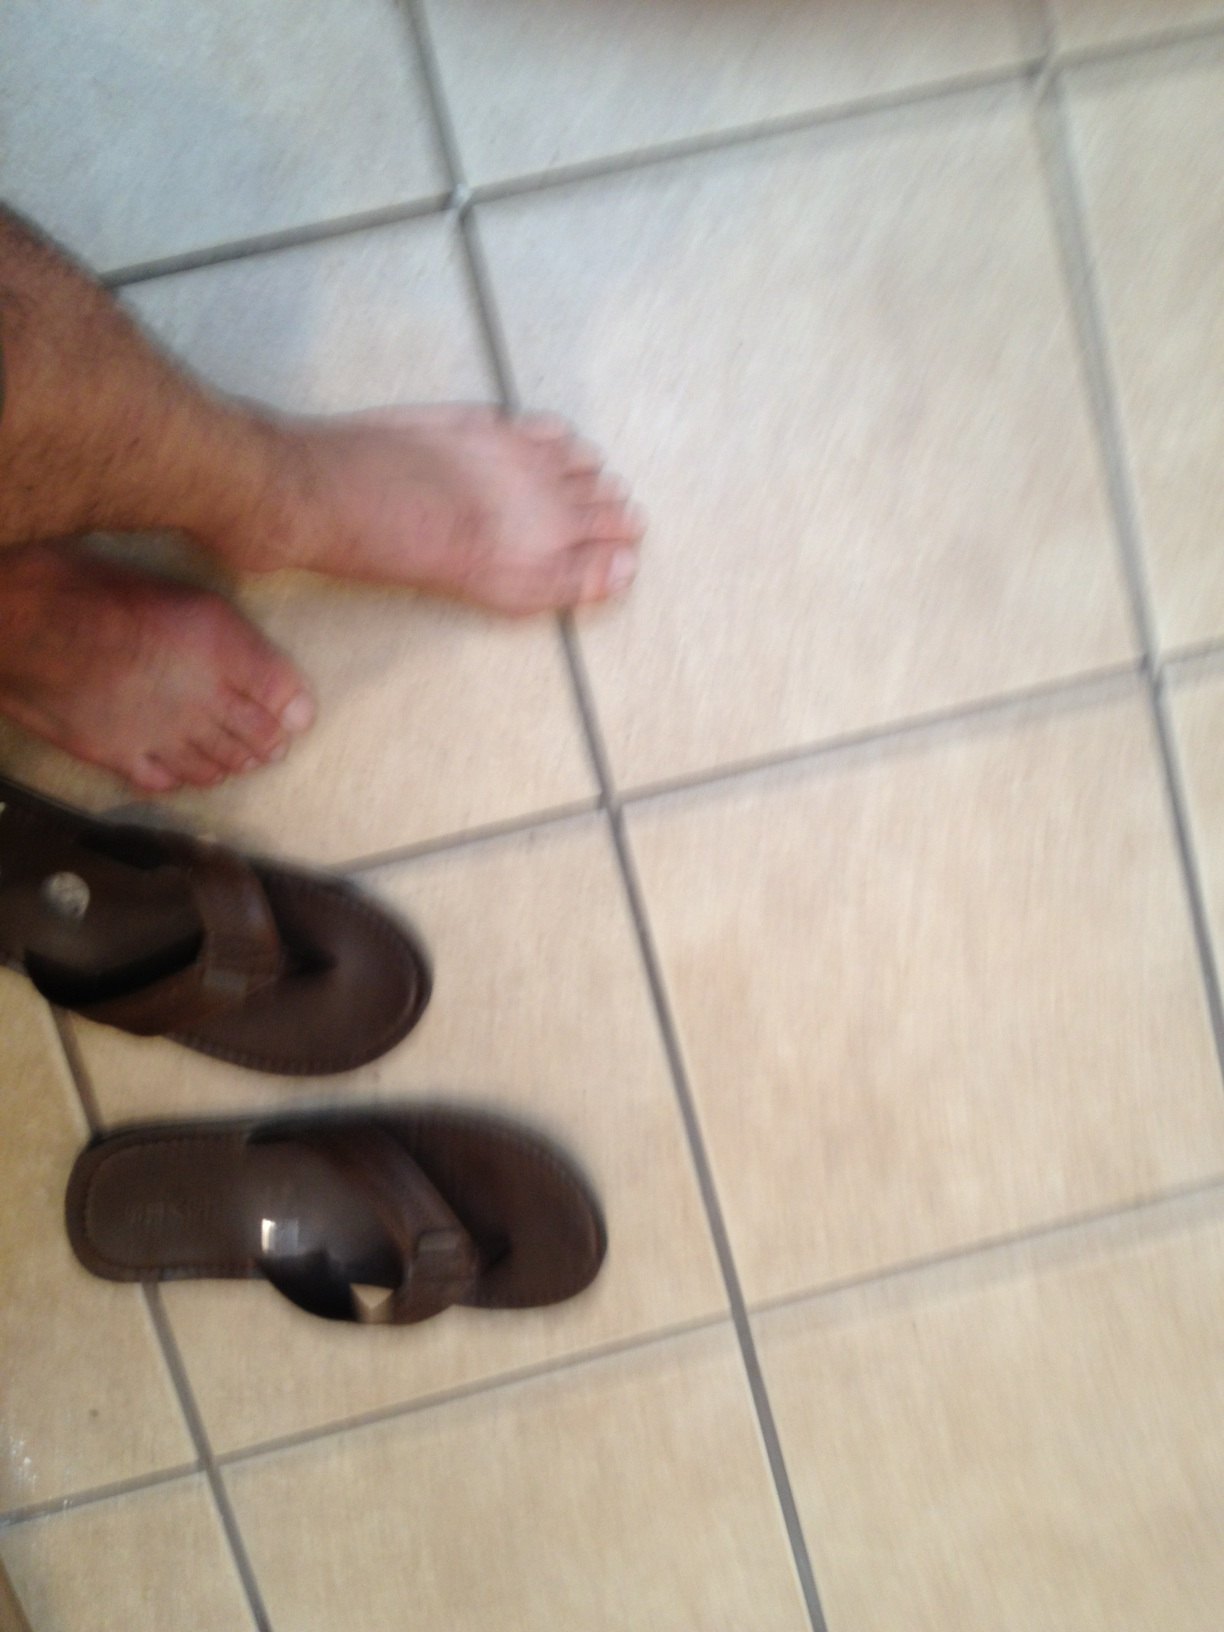What is that? from Vizwiz flip flops 